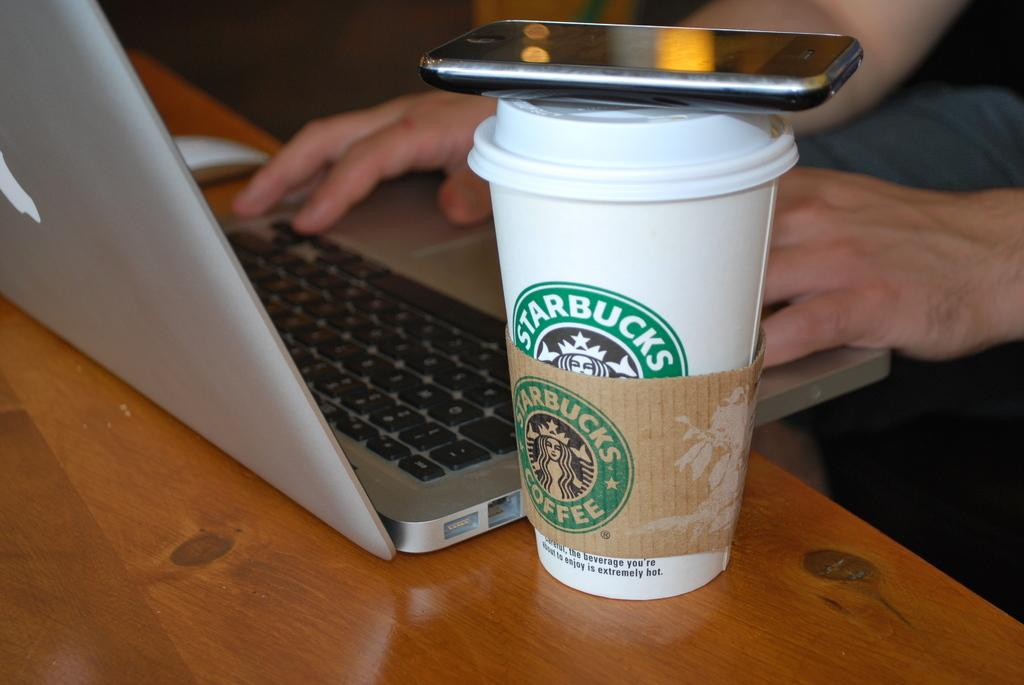<image>
Create a compact narrative representing the image presented. A Starbucks cup has a phone resting on top of it. 